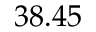<formula> <loc_0><loc_0><loc_500><loc_500>3 8 . 4 5</formula> 